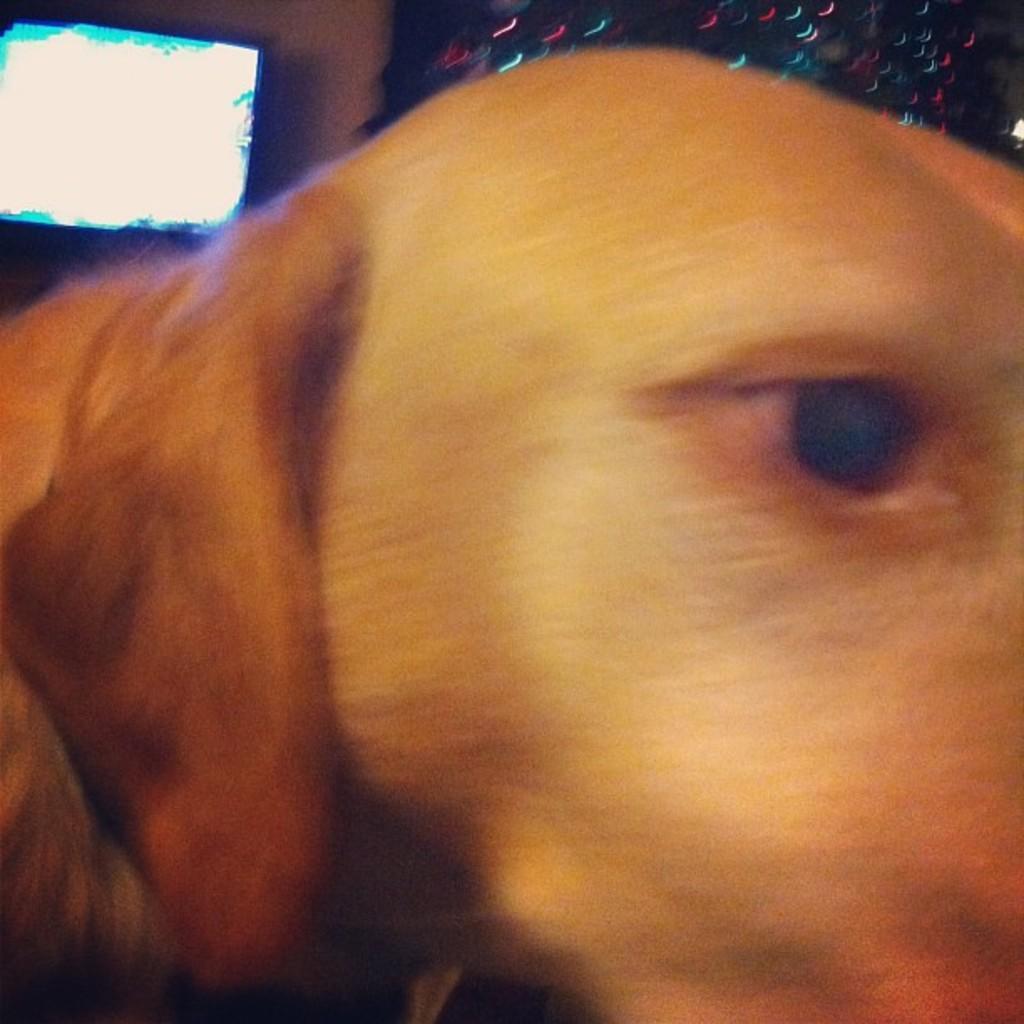Could you give a brief overview of what you see in this image? In this image we can see dog's face and at the background of the image there is television attached to the wall. 